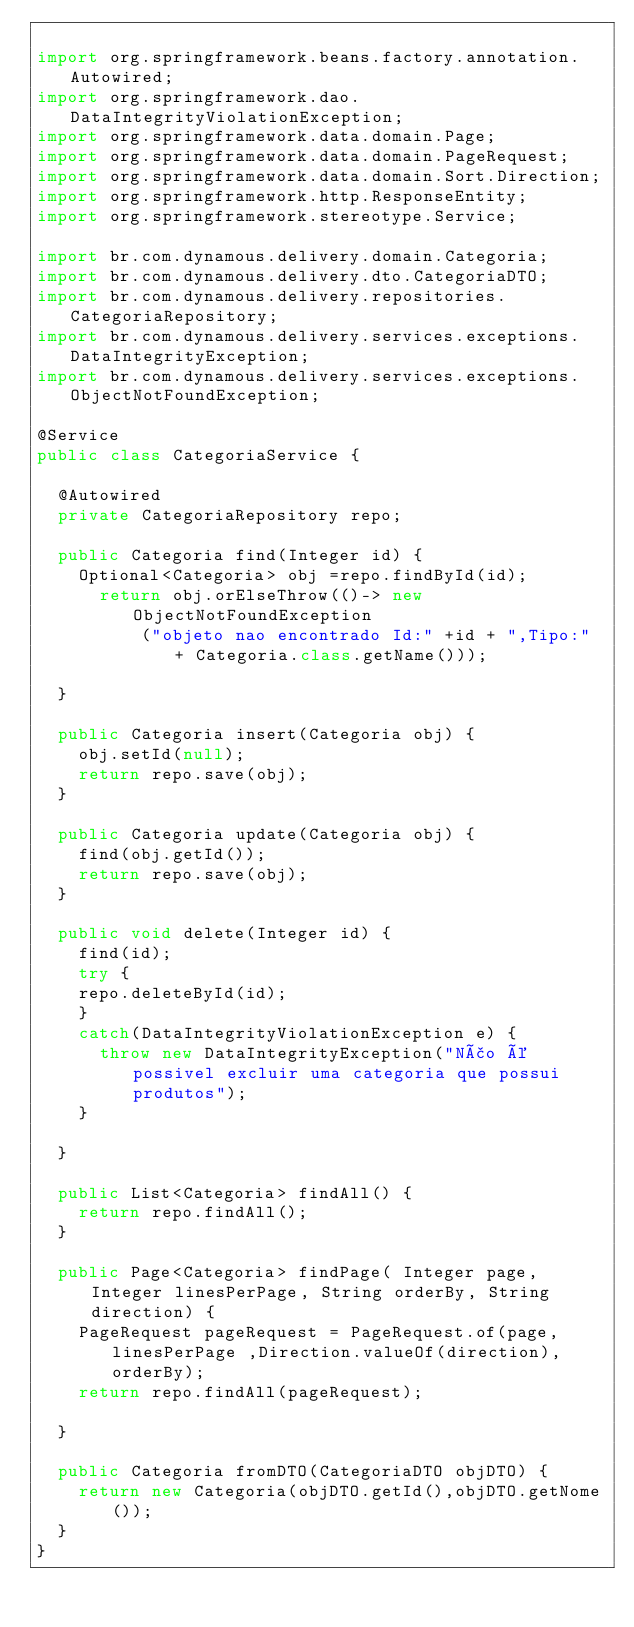Convert code to text. <code><loc_0><loc_0><loc_500><loc_500><_Java_>
import org.springframework.beans.factory.annotation.Autowired;
import org.springframework.dao.DataIntegrityViolationException;
import org.springframework.data.domain.Page;
import org.springframework.data.domain.PageRequest;
import org.springframework.data.domain.Sort.Direction;
import org.springframework.http.ResponseEntity;
import org.springframework.stereotype.Service;

import br.com.dynamous.delivery.domain.Categoria;
import br.com.dynamous.delivery.dto.CategoriaDTO;
import br.com.dynamous.delivery.repositories.CategoriaRepository;
import br.com.dynamous.delivery.services.exceptions.DataIntegrityException;
import br.com.dynamous.delivery.services.exceptions.ObjectNotFoundException;

@Service
public class CategoriaService {
	
	@Autowired
	private CategoriaRepository repo;
	
	public Categoria find(Integer id) {	
		Optional<Categoria> obj =repo.findById(id);		
			return obj.orElseThrow(()-> new ObjectNotFoundException
					("objeto nao encontrado Id:" +id + ",Tipo:" + Categoria.class.getName()));	
		
	}
	
	public Categoria insert(Categoria obj) {
		obj.setId(null);
		return repo.save(obj);
	}

	public Categoria update(Categoria obj) {
		find(obj.getId());
		return repo.save(obj);
	}

	public void delete(Integer id) {
		find(id);
		try {
		repo.deleteById(id);
		}
		catch(DataIntegrityViolationException e) {
			throw new DataIntegrityException("Não é possivel excluir uma categoria que possui produtos");
		}
		
	}

	public List<Categoria> findAll() {
		return repo.findAll();
	}

	public Page<Categoria> findPage( Integer page, Integer linesPerPage, String orderBy, String direction) {	
		PageRequest pageRequest = PageRequest.of(page, linesPerPage ,Direction.valueOf(direction),orderBy);	
		return repo.findAll(pageRequest);
		
	}
	
	public Categoria fromDTO(CategoriaDTO objDTO) {
		return new Categoria(objDTO.getId(),objDTO.getNome());
	}
}
</code> 